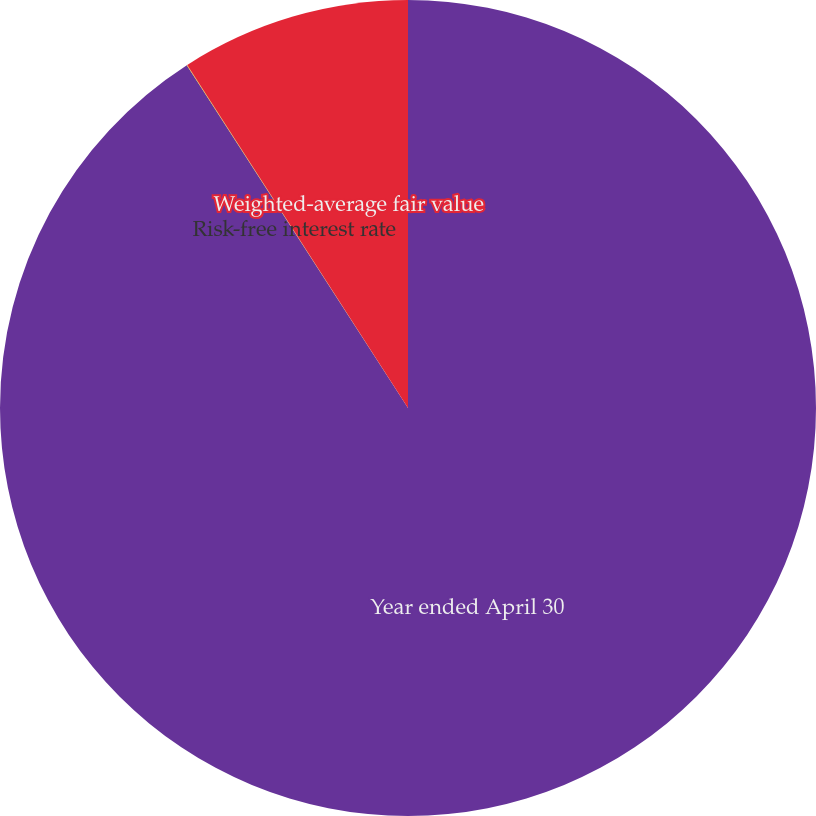<chart> <loc_0><loc_0><loc_500><loc_500><pie_chart><fcel>Year ended April 30<fcel>Risk-free interest rate<fcel>Weighted-average fair value<nl><fcel>90.88%<fcel>0.02%<fcel>9.1%<nl></chart> 